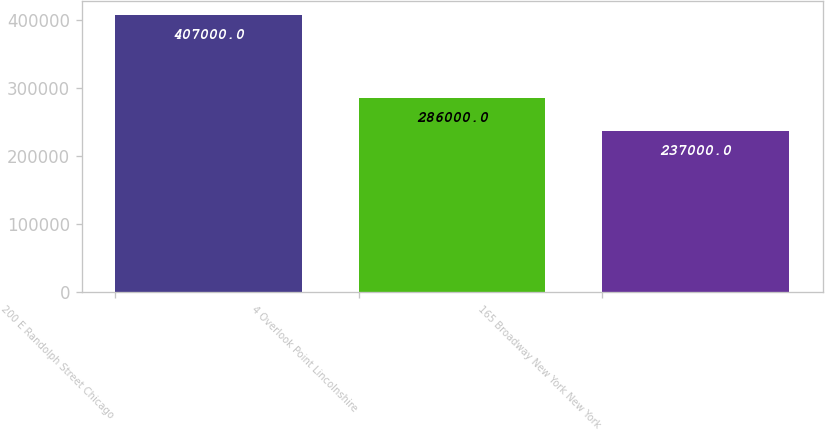<chart> <loc_0><loc_0><loc_500><loc_500><bar_chart><fcel>200 E Randolph Street Chicago<fcel>4 Overlook Point Lincolnshire<fcel>165 Broadway New York New York<nl><fcel>407000<fcel>286000<fcel>237000<nl></chart> 